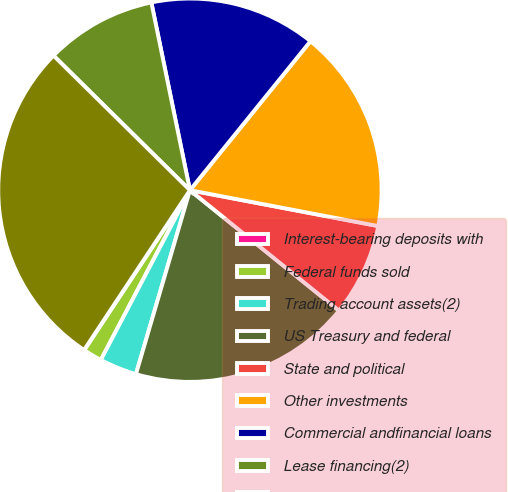Convert chart to OTSL. <chart><loc_0><loc_0><loc_500><loc_500><pie_chart><fcel>Interest-bearing deposits with<fcel>Federal funds sold<fcel>Trading account assets(2)<fcel>US Treasury and federal<fcel>State and political<fcel>Other investments<fcel>Commercial andfinancial loans<fcel>Lease financing(2)<fcel>Total interest-earning<nl><fcel>0.03%<fcel>1.59%<fcel>3.15%<fcel>18.73%<fcel>7.82%<fcel>17.17%<fcel>14.05%<fcel>9.38%<fcel>28.08%<nl></chart> 